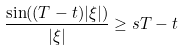<formula> <loc_0><loc_0><loc_500><loc_500>\frac { \sin ( ( T - t ) | \xi | ) } { | \xi | } \geq s T - t</formula> 